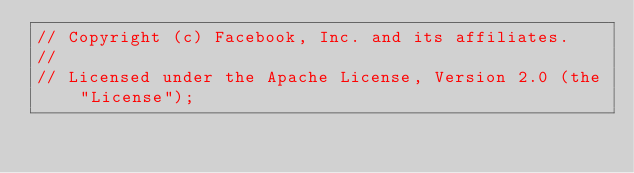<code> <loc_0><loc_0><loc_500><loc_500><_Rust_>// Copyright (c) Facebook, Inc. and its affiliates.
//
// Licensed under the Apache License, Version 2.0 (the "License");</code> 